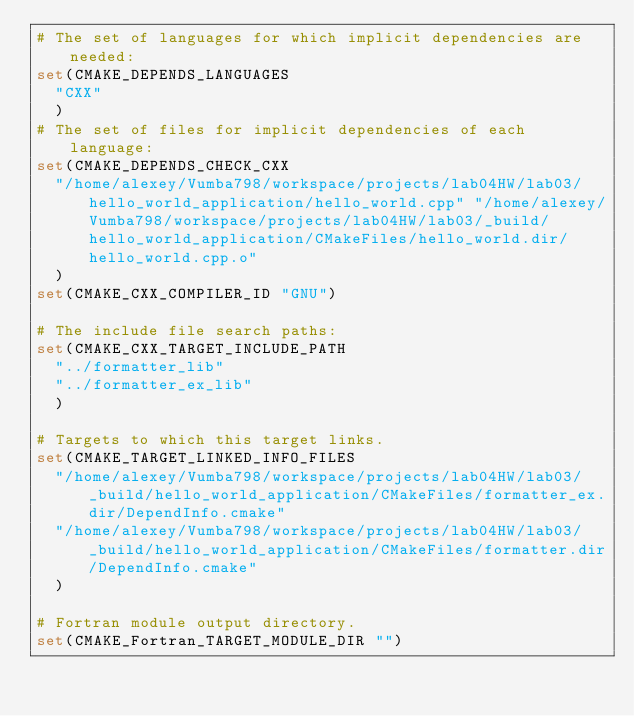Convert code to text. <code><loc_0><loc_0><loc_500><loc_500><_CMake_># The set of languages for which implicit dependencies are needed:
set(CMAKE_DEPENDS_LANGUAGES
  "CXX"
  )
# The set of files for implicit dependencies of each language:
set(CMAKE_DEPENDS_CHECK_CXX
  "/home/alexey/Vumba798/workspace/projects/lab04HW/lab03/hello_world_application/hello_world.cpp" "/home/alexey/Vumba798/workspace/projects/lab04HW/lab03/_build/hello_world_application/CMakeFiles/hello_world.dir/hello_world.cpp.o"
  )
set(CMAKE_CXX_COMPILER_ID "GNU")

# The include file search paths:
set(CMAKE_CXX_TARGET_INCLUDE_PATH
  "../formatter_lib"
  "../formatter_ex_lib"
  )

# Targets to which this target links.
set(CMAKE_TARGET_LINKED_INFO_FILES
  "/home/alexey/Vumba798/workspace/projects/lab04HW/lab03/_build/hello_world_application/CMakeFiles/formatter_ex.dir/DependInfo.cmake"
  "/home/alexey/Vumba798/workspace/projects/lab04HW/lab03/_build/hello_world_application/CMakeFiles/formatter.dir/DependInfo.cmake"
  )

# Fortran module output directory.
set(CMAKE_Fortran_TARGET_MODULE_DIR "")
</code> 